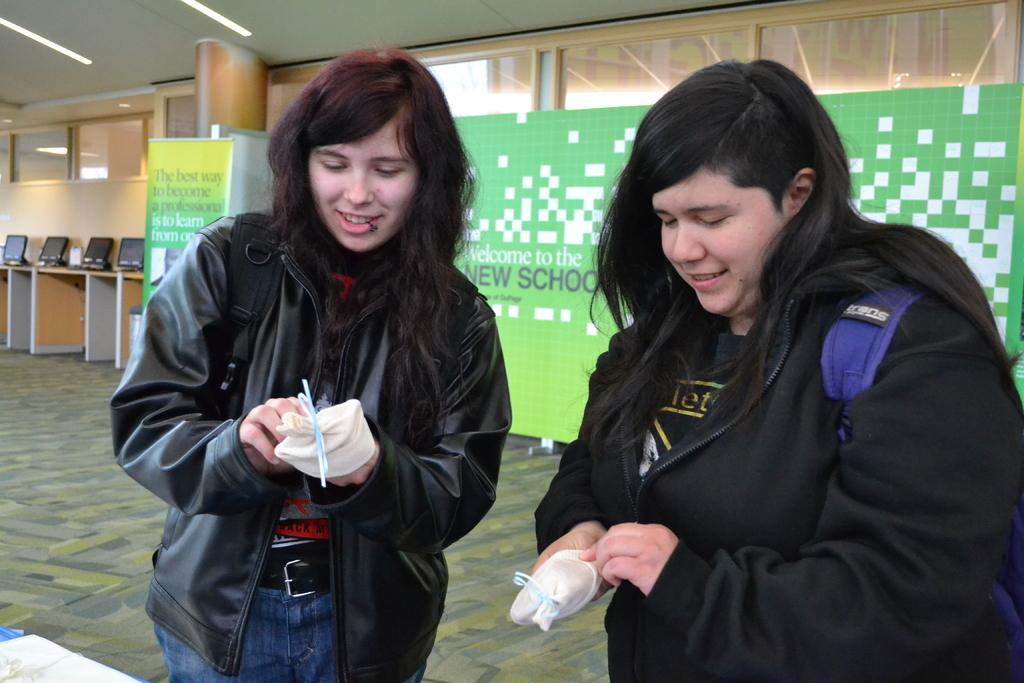How many people are in the image? There are two girls in the center of the image. What can be seen in the background of the image? There is a poster in the background of the image. What is located on the left side of the image? There are monitors on the left side of the image. What type of flame can be seen on the girls' faces in the image? There is no flame present on the girls' faces in the image. How much credit is visible in the image? There is no reference to credit in the image. 